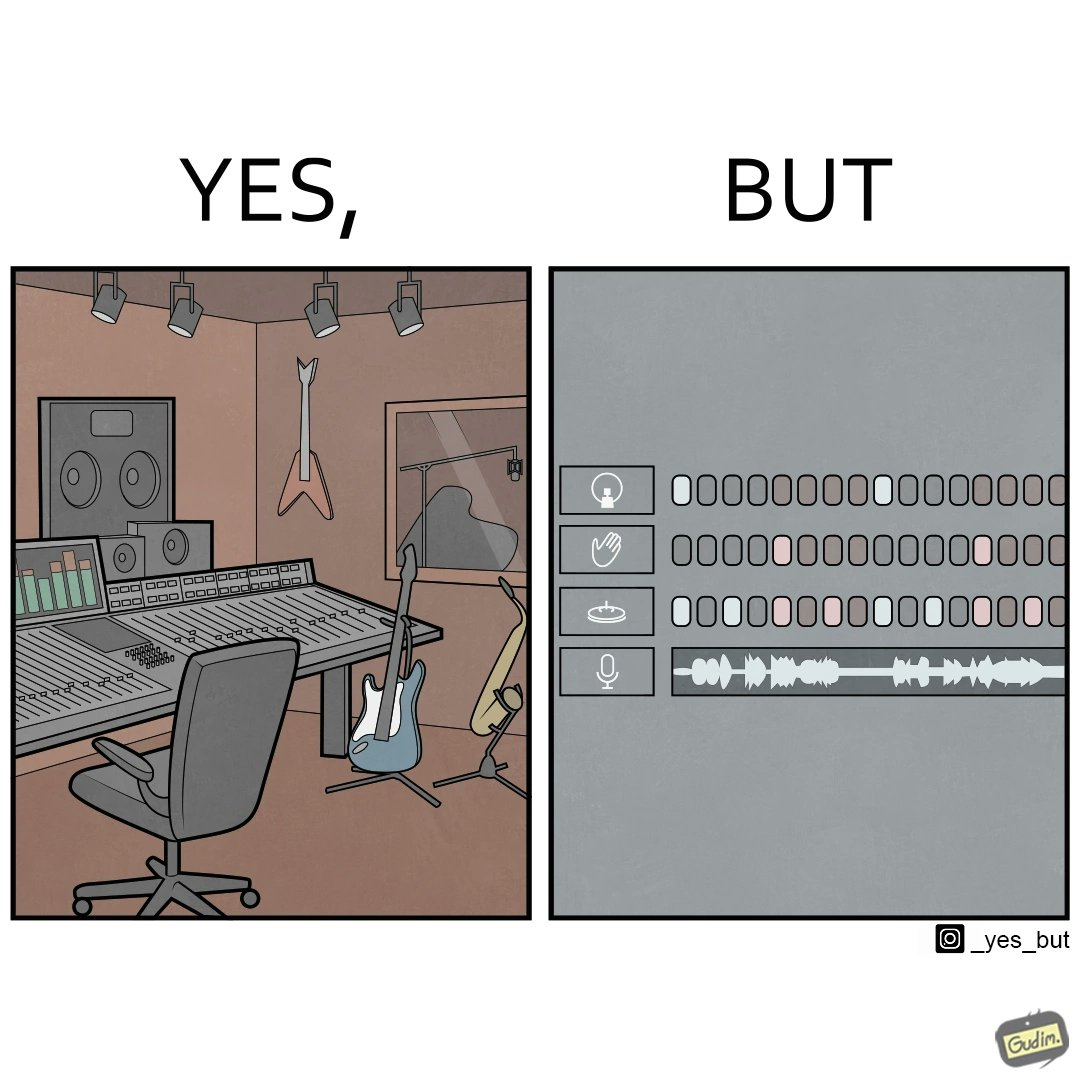Describe the satirical element in this image. The image overall is funny because even though people have great music studios and instruments to create and record music, they use electronic replacements of the musical instruments to achieve the task. 